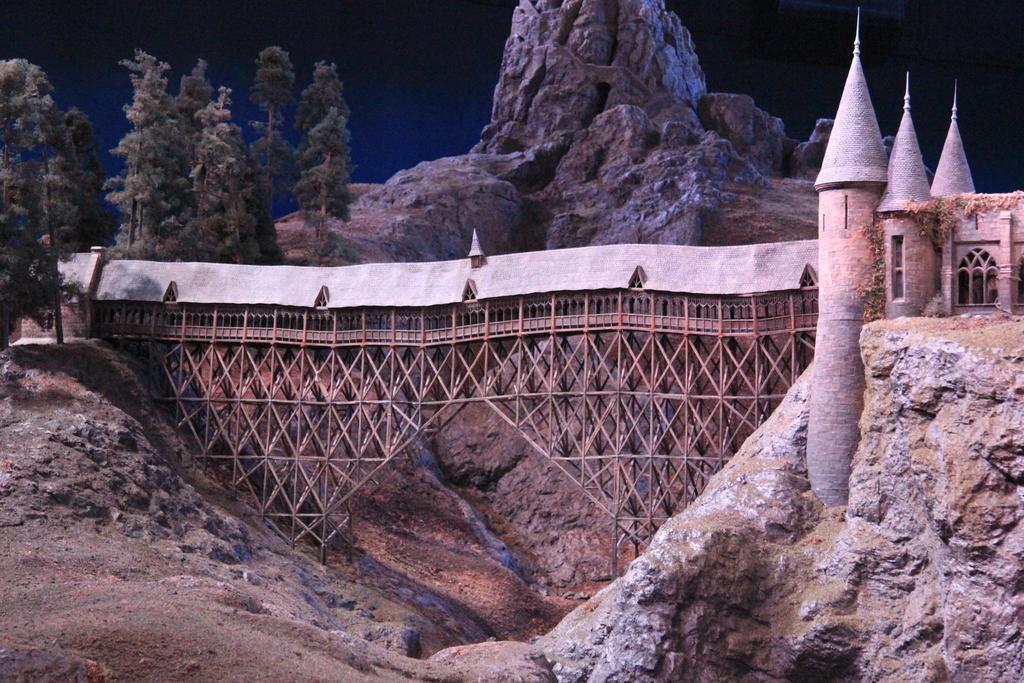In one or two sentences, can you explain what this image depicts? In the center of the image there is a bridge. On the right side of the image a fort is there. On the left side of the image trees are there. In the background of the image mountains are there. At the top of the image there is a sky. 